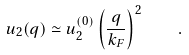Convert formula to latex. <formula><loc_0><loc_0><loc_500><loc_500>u _ { 2 } ( { q } ) \simeq u _ { 2 } ^ { ( 0 ) } \left ( \frac { q } { k _ { F } } \right ) ^ { 2 } \quad .</formula> 